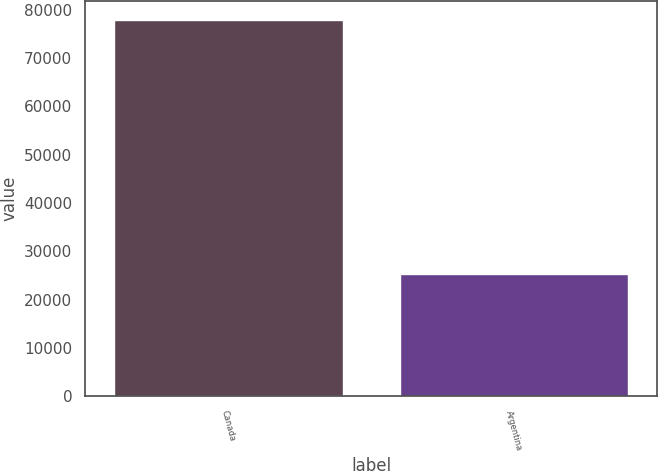Convert chart. <chart><loc_0><loc_0><loc_500><loc_500><bar_chart><fcel>Canada<fcel>Argentina<nl><fcel>77962<fcel>25361<nl></chart> 